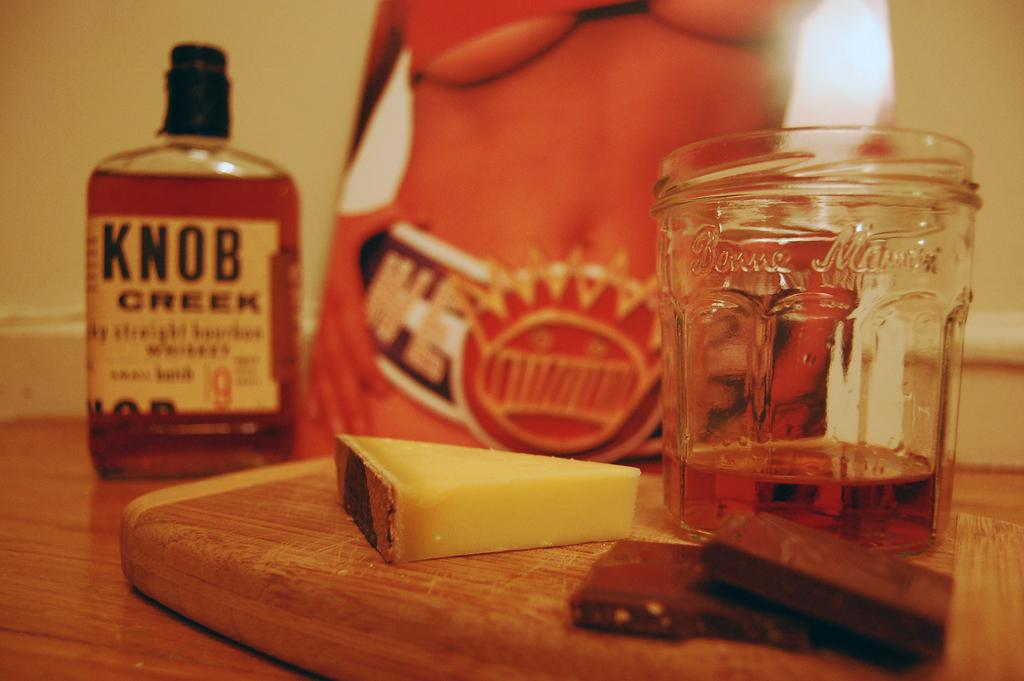<image>
Give a short and clear explanation of the subsequent image. A bottle of Knob Creek in the background, a picture of a torso, and a glass next to chocolate and chees in the foreground. 